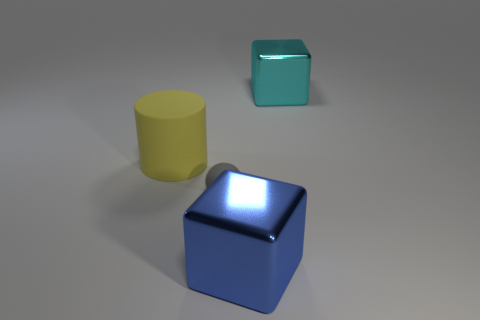Is there anything else that is the same size as the gray ball?
Your answer should be compact. No. How many gray spheres have the same material as the big cyan block?
Make the answer very short. 0. Does the big metallic thing that is in front of the cyan shiny object have the same shape as the big metallic object that is behind the blue metal thing?
Offer a terse response. Yes. There is a big thing on the left side of the big blue cube; what is its color?
Offer a very short reply. Yellow. Is there a blue shiny thing that has the same shape as the cyan metallic object?
Your response must be concise. Yes. What material is the large blue thing?
Keep it short and to the point. Metal. There is a object that is on the right side of the tiny gray object and in front of the cyan shiny block; how big is it?
Your response must be concise. Large. What number of metal blocks are there?
Keep it short and to the point. 2. Is the number of small things less than the number of large gray metallic blocks?
Offer a terse response. No. There is a cylinder that is the same size as the blue object; what is its material?
Your answer should be very brief. Rubber. 